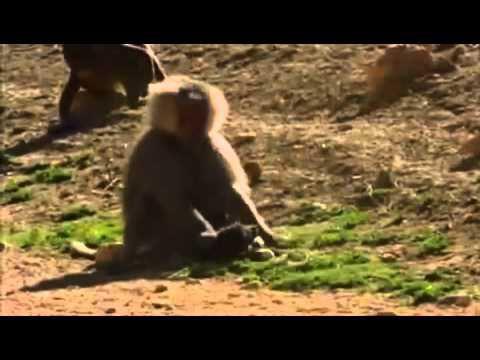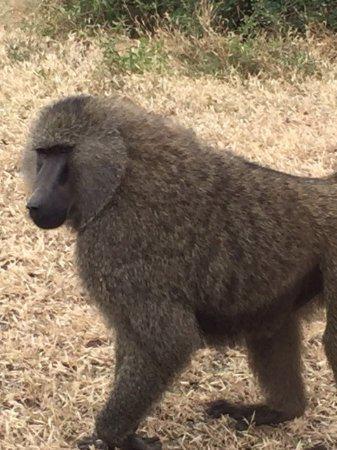The first image is the image on the left, the second image is the image on the right. Considering the images on both sides, is "An image shows exactly one baboon, which is walking on all fours on the ground." valid? Answer yes or no. Yes. The first image is the image on the left, the second image is the image on the right. For the images shown, is this caption "There are at least two monkeys in the image on the right." true? Answer yes or no. No. 